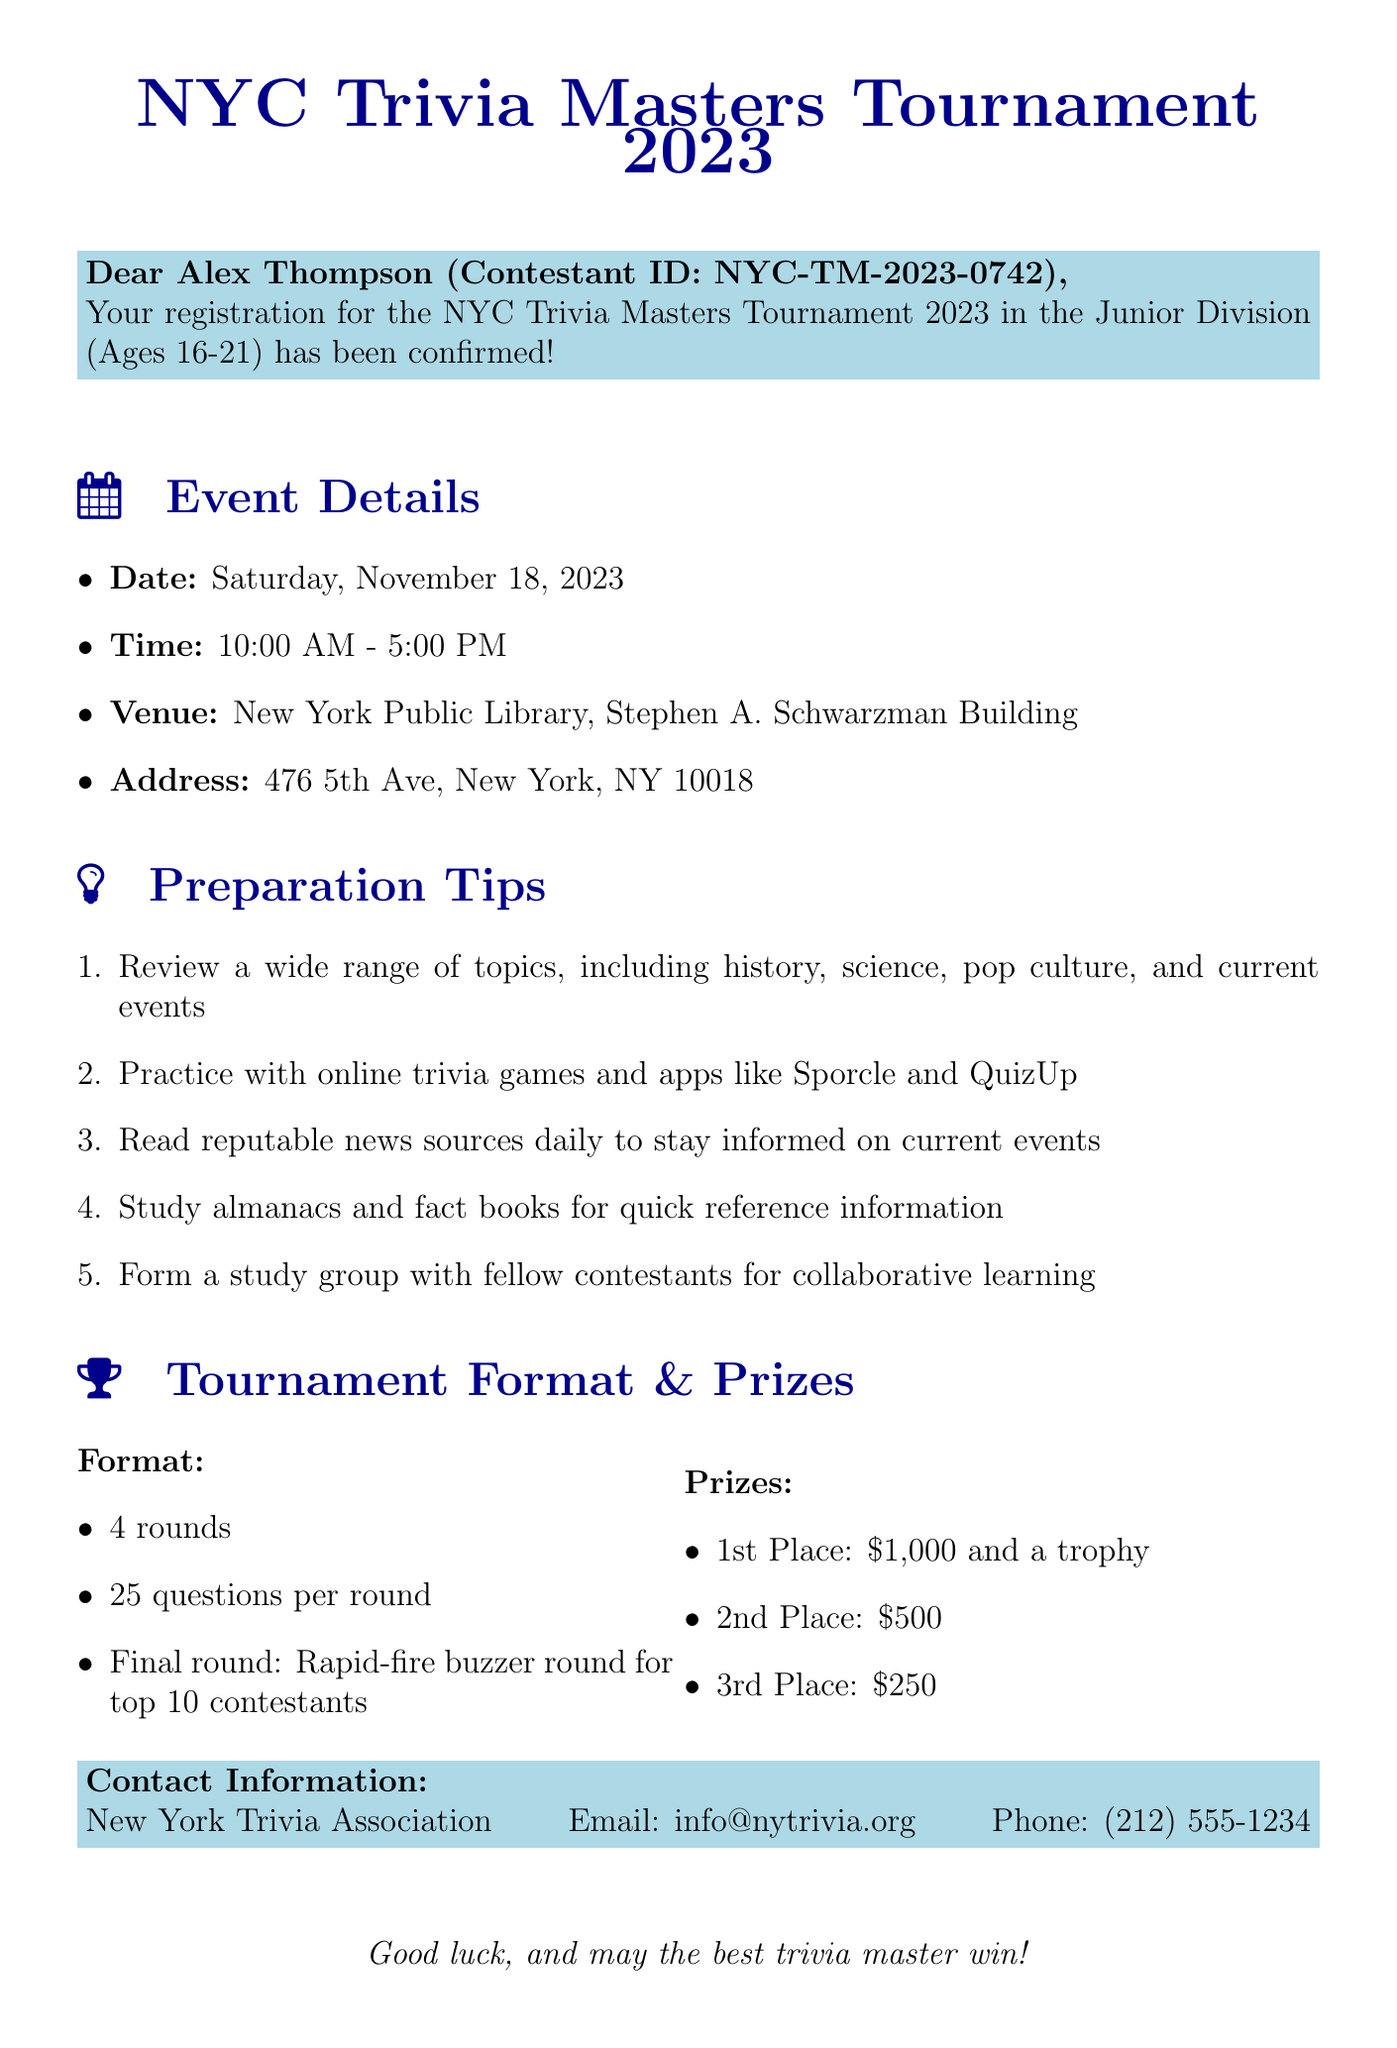What is the date of the tournament? The date of the tournament is explicitly mentioned in the event details of the document.
Answer: Saturday, November 18, 2023 What is the venue for the trivia tournament? The venue is provided in the event details section, specifying where the event will take place.
Answer: New York Public Library, Stephen A. Schwarzman Building How many rounds will there be in the tournament? The number of rounds is stated in the tournament format section of the document.
Answer: 4 What is the prize for 1st place? The prize for 1st place is listed in the prizes section of the document.
Answer: $1,000 and a trophy What is one preparation tip suggested in the email? The preparation tips are listed, and any one of them can be selected to answer this question.
Answer: Review a wide range of topics, including history, science, pop culture, and current events What is the format of the final round? The final round format is mentioned in the tournament format section, detailing how the last segment will be conducted.
Answer: Rapid-fire buzzer round for top 10 contestants Who is the organizer of the tournament? The contact information section provides the name of the organizing body responsible for the event.
Answer: New York Trivia Association What age category does Alex Thompson belong to? Alex's category is specified in the registration confirmation section of the document.
Answer: Junior Division (Ages 16-21) 